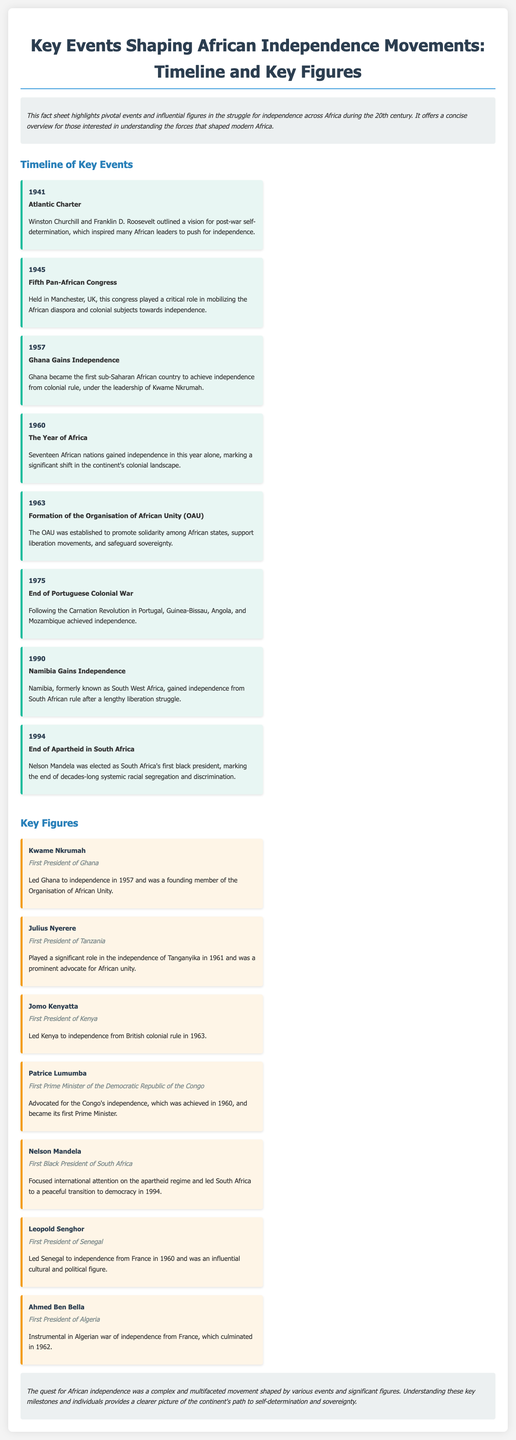What year did Ghana gain independence? The document states that Ghana became independent in 1957.
Answer: 1957 Who was the first Prime Minister of the Democratic Republic of the Congo? According to the document, Patrice Lumumba was the first Prime Minister of the Democratic Republic of the Congo.
Answer: Patrice Lumumba What significant event occurred in 1960 related to African independence? The document mentions that seventeen African nations gained independence in 1960, highlighting it as "The Year of Africa."
Answer: The Year of Africa Who was the first black president of South Africa? The document states that Nelson Mandela was the first black president of South Africa.
Answer: Nelson Mandela What was the Atlantic Charter? The document explains that it outlined a vision for post-war self-determination, inspiring many African leaders toward independence.
Answer: A vision for post-war self-determination Which figure was instrumental in the Algerian war of independence? The document specifies that Ahmed Ben Bella was instrumental in the Algerian war of independence from France.
Answer: Ahmed Ben Bella What was established in 1963 to promote solidarity among African states? The document indicates that the Organisation of African Unity (OAU) was established for this purpose.
Answer: Organisation of African Unity (OAU) How many African nations gained independence in 1960? The document states that seventeen African nations gained independence in that year.
Answer: Seventeen 